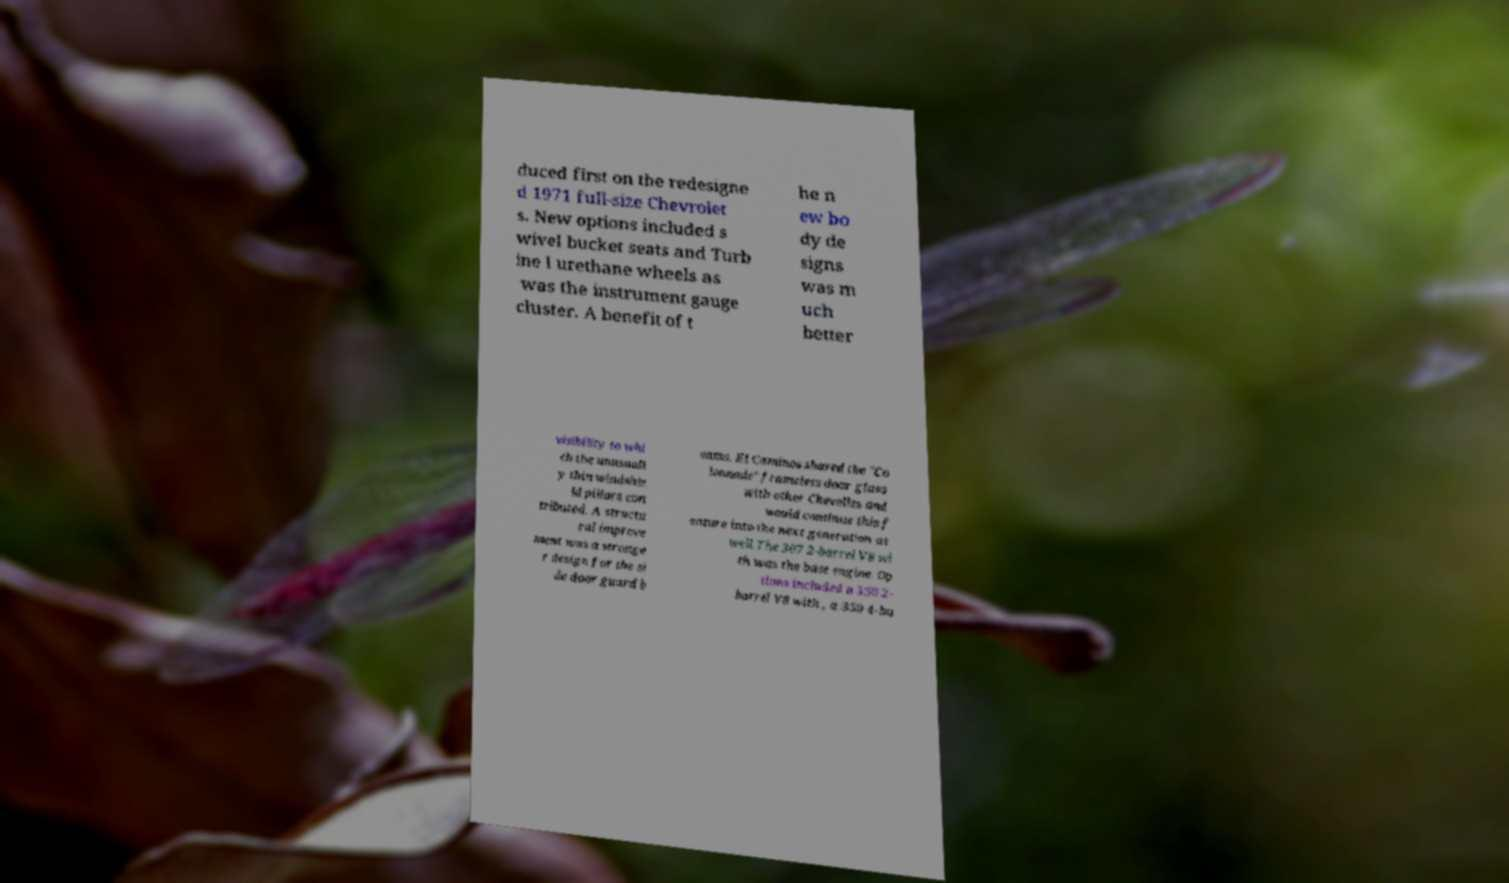Can you read and provide the text displayed in the image?This photo seems to have some interesting text. Can you extract and type it out for me? duced first on the redesigne d 1971 full-size Chevrolet s. New options included s wivel bucket seats and Turb ine I urethane wheels as was the instrument gauge cluster. A benefit of t he n ew bo dy de signs was m uch better visibility to whi ch the unusuall y thin windshie ld pillars con tributed. A structu ral improve ment was a stronge r design for the si de door guard b eams. El Caminos shared the "Co lonnade" frameless door glass with other Chevelles and would continue this f eature into the next generation as well.The 307 2-barrel V8 wi th was the base engine. Op tions included a 350 2- barrel V8 with , a 350 4-ba 